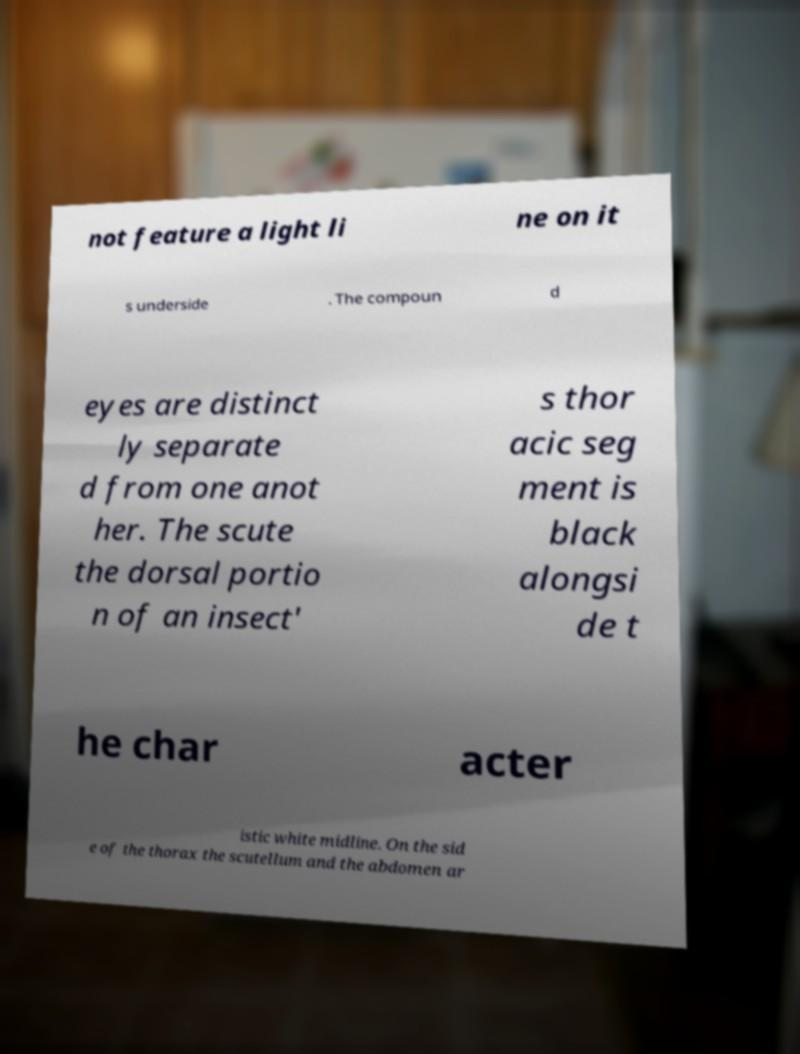There's text embedded in this image that I need extracted. Can you transcribe it verbatim? not feature a light li ne on it s underside . The compoun d eyes are distinct ly separate d from one anot her. The scute the dorsal portio n of an insect' s thor acic seg ment is black alongsi de t he char acter istic white midline. On the sid e of the thorax the scutellum and the abdomen ar 